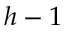Convert formula to latex. <formula><loc_0><loc_0><loc_500><loc_500>h - 1</formula> 